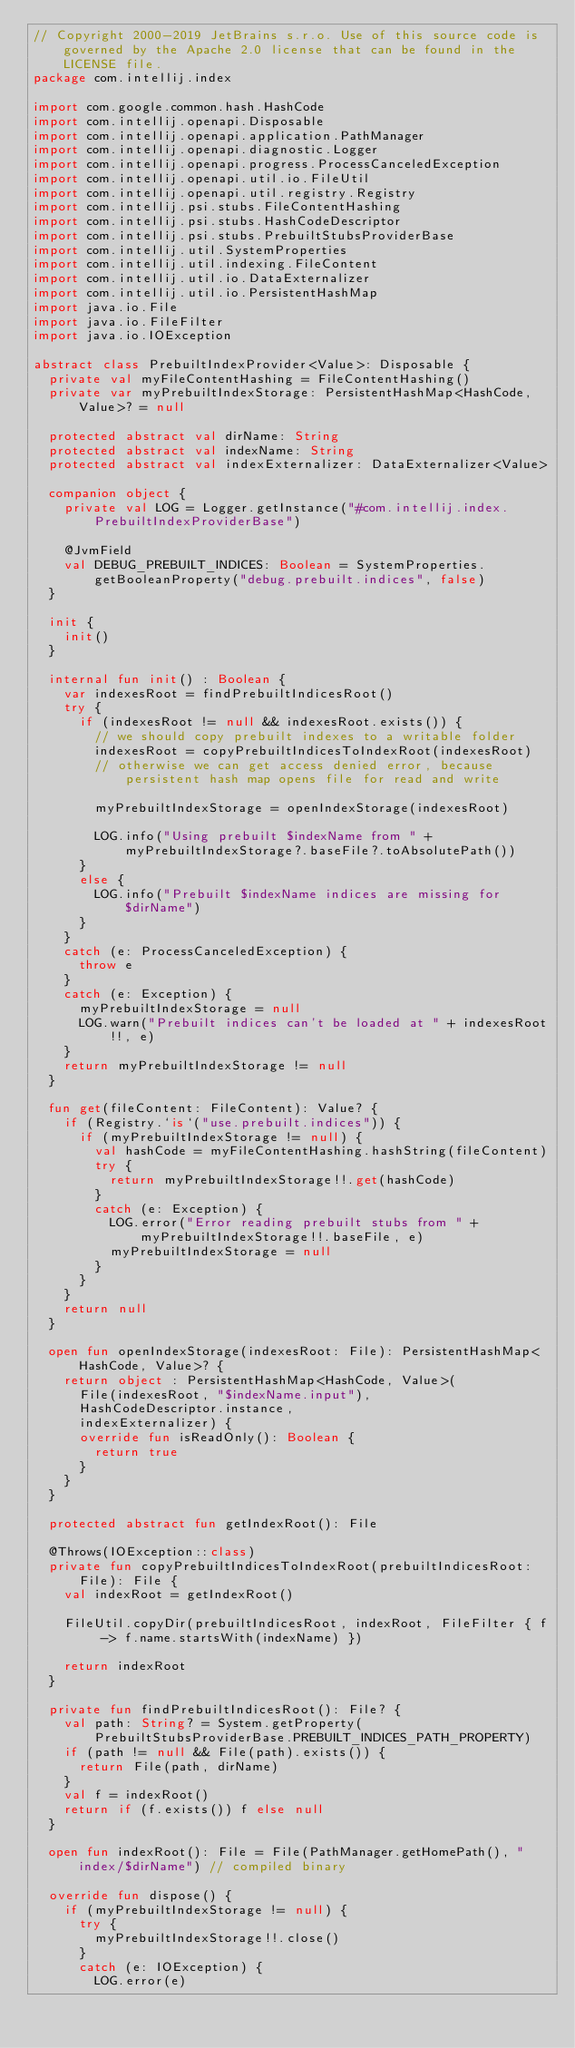<code> <loc_0><loc_0><loc_500><loc_500><_Kotlin_>// Copyright 2000-2019 JetBrains s.r.o. Use of this source code is governed by the Apache 2.0 license that can be found in the LICENSE file.
package com.intellij.index

import com.google.common.hash.HashCode
import com.intellij.openapi.Disposable
import com.intellij.openapi.application.PathManager
import com.intellij.openapi.diagnostic.Logger
import com.intellij.openapi.progress.ProcessCanceledException
import com.intellij.openapi.util.io.FileUtil
import com.intellij.openapi.util.registry.Registry
import com.intellij.psi.stubs.FileContentHashing
import com.intellij.psi.stubs.HashCodeDescriptor
import com.intellij.psi.stubs.PrebuiltStubsProviderBase
import com.intellij.util.SystemProperties
import com.intellij.util.indexing.FileContent
import com.intellij.util.io.DataExternalizer
import com.intellij.util.io.PersistentHashMap
import java.io.File
import java.io.FileFilter
import java.io.IOException

abstract class PrebuiltIndexProvider<Value>: Disposable {
  private val myFileContentHashing = FileContentHashing()
  private var myPrebuiltIndexStorage: PersistentHashMap<HashCode, Value>? = null

  protected abstract val dirName: String
  protected abstract val indexName: String
  protected abstract val indexExternalizer: DataExternalizer<Value>

  companion object {
    private val LOG = Logger.getInstance("#com.intellij.index.PrebuiltIndexProviderBase")

    @JvmField
    val DEBUG_PREBUILT_INDICES: Boolean = SystemProperties.getBooleanProperty("debug.prebuilt.indices", false)
  }

  init {
    init()
  }

  internal fun init() : Boolean {
    var indexesRoot = findPrebuiltIndicesRoot()
    try {
      if (indexesRoot != null && indexesRoot.exists()) {
        // we should copy prebuilt indexes to a writable folder
        indexesRoot = copyPrebuiltIndicesToIndexRoot(indexesRoot)
        // otherwise we can get access denied error, because persistent hash map opens file for read and write

        myPrebuiltIndexStorage = openIndexStorage(indexesRoot)

        LOG.info("Using prebuilt $indexName from " + myPrebuiltIndexStorage?.baseFile?.toAbsolutePath())
      }
      else {
        LOG.info("Prebuilt $indexName indices are missing for $dirName")
      }
    }
    catch (e: ProcessCanceledException) {
      throw e
    }
    catch (e: Exception) {
      myPrebuiltIndexStorage = null
      LOG.warn("Prebuilt indices can't be loaded at " + indexesRoot!!, e)
    }
    return myPrebuiltIndexStorage != null
  }

  fun get(fileContent: FileContent): Value? {
    if (Registry.`is`("use.prebuilt.indices")) {
      if (myPrebuiltIndexStorage != null) {
        val hashCode = myFileContentHashing.hashString(fileContent)
        try {
          return myPrebuiltIndexStorage!!.get(hashCode)
        }
        catch (e: Exception) {
          LOG.error("Error reading prebuilt stubs from " + myPrebuiltIndexStorage!!.baseFile, e)
          myPrebuiltIndexStorage = null
        }
      }
    }
    return null
  }

  open fun openIndexStorage(indexesRoot: File): PersistentHashMap<HashCode, Value>? {
    return object : PersistentHashMap<HashCode, Value>(
      File(indexesRoot, "$indexName.input"),
      HashCodeDescriptor.instance,
      indexExternalizer) {
      override fun isReadOnly(): Boolean {
        return true
      }
    }
  }

  protected abstract fun getIndexRoot(): File

  @Throws(IOException::class)
  private fun copyPrebuiltIndicesToIndexRoot(prebuiltIndicesRoot: File): File {
    val indexRoot = getIndexRoot()

    FileUtil.copyDir(prebuiltIndicesRoot, indexRoot, FileFilter { f -> f.name.startsWith(indexName) })

    return indexRoot
  }

  private fun findPrebuiltIndicesRoot(): File? {
    val path: String? = System.getProperty(PrebuiltStubsProviderBase.PREBUILT_INDICES_PATH_PROPERTY)
    if (path != null && File(path).exists()) {
      return File(path, dirName)
    }
    val f = indexRoot()
    return if (f.exists()) f else null
  }

  open fun indexRoot(): File = File(PathManager.getHomePath(), "index/$dirName") // compiled binary

  override fun dispose() {
    if (myPrebuiltIndexStorage != null) {
      try {
        myPrebuiltIndexStorage!!.close()
      }
      catch (e: IOException) {
        LOG.error(e)</code> 